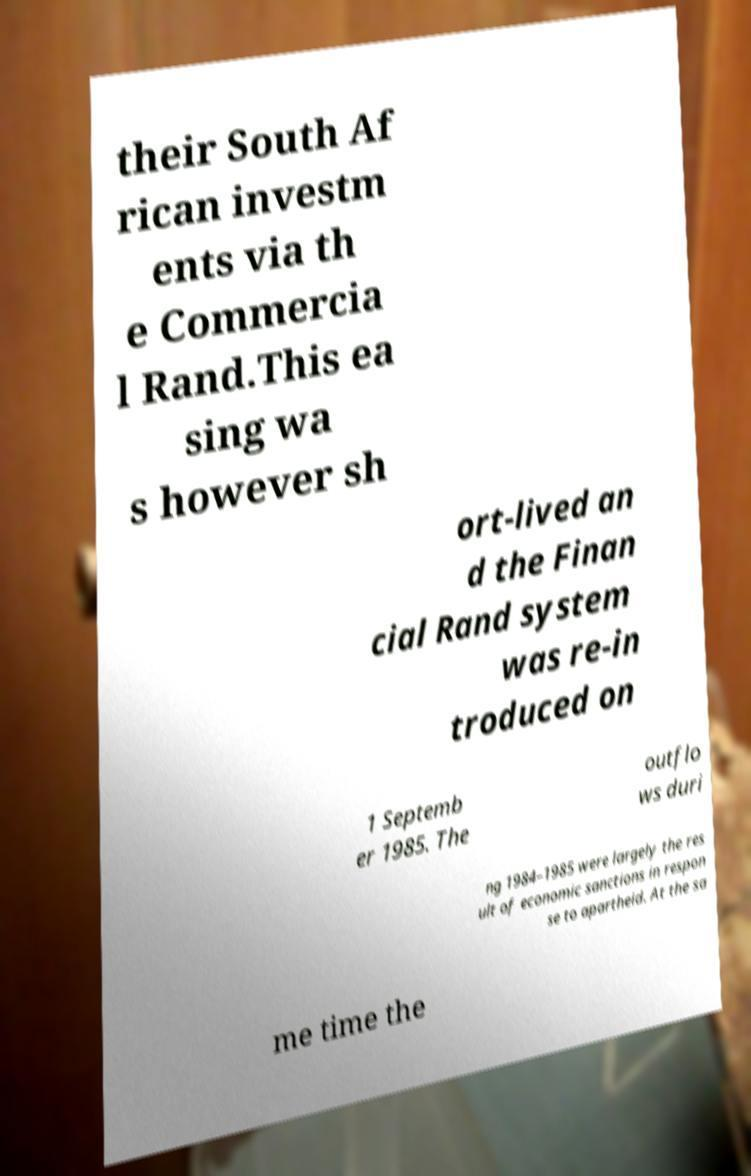Could you assist in decoding the text presented in this image and type it out clearly? their South Af rican investm ents via th e Commercia l Rand.This ea sing wa s however sh ort-lived an d the Finan cial Rand system was re-in troduced on 1 Septemb er 1985. The outflo ws duri ng 1984–1985 were largely the res ult of economic sanctions in respon se to apartheid. At the sa me time the 